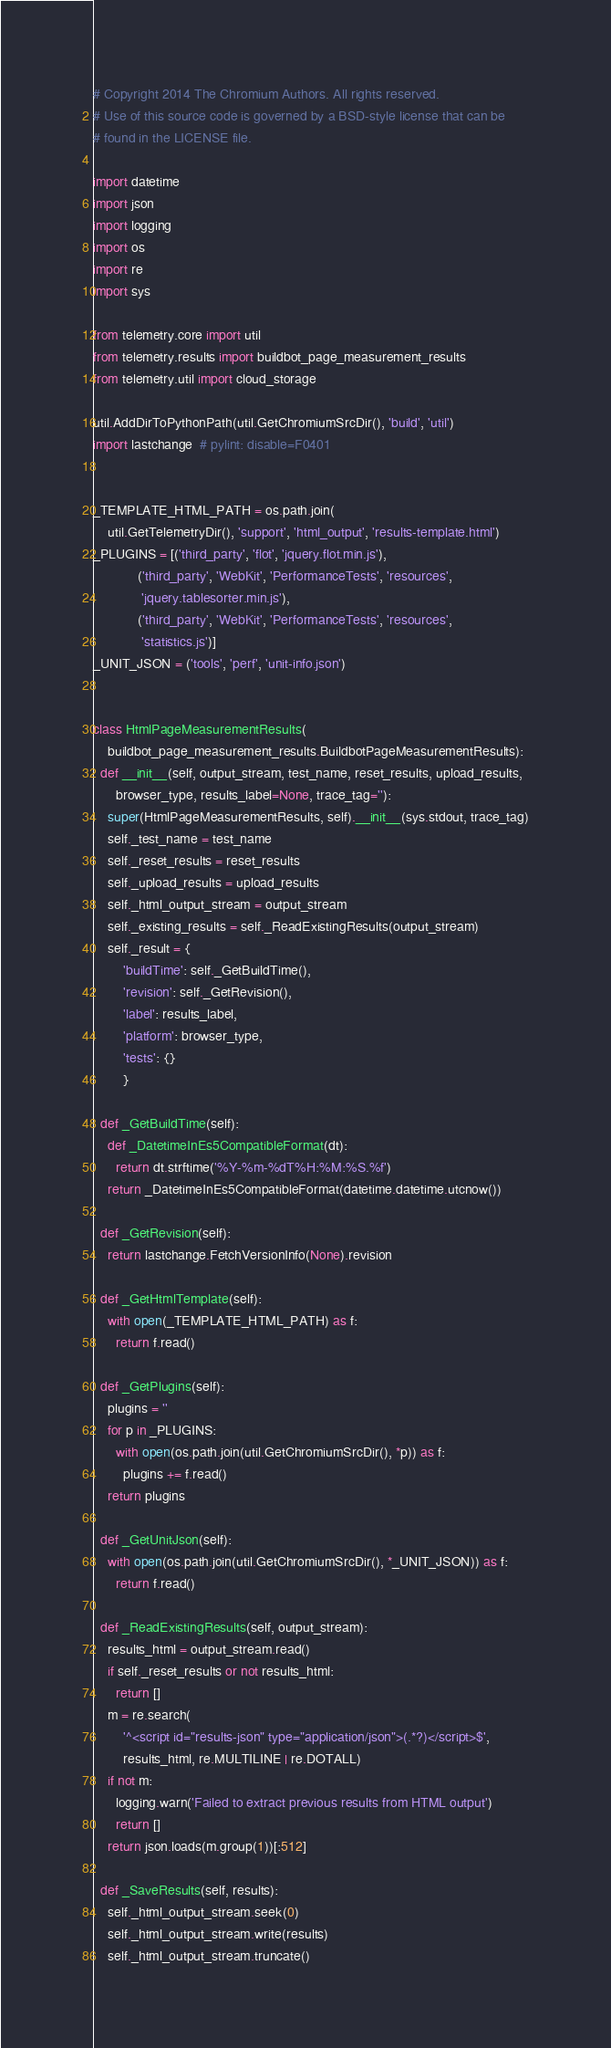<code> <loc_0><loc_0><loc_500><loc_500><_Python_># Copyright 2014 The Chromium Authors. All rights reserved.
# Use of this source code is governed by a BSD-style license that can be
# found in the LICENSE file.

import datetime
import json
import logging
import os
import re
import sys

from telemetry.core import util
from telemetry.results import buildbot_page_measurement_results
from telemetry.util import cloud_storage

util.AddDirToPythonPath(util.GetChromiumSrcDir(), 'build', 'util')
import lastchange  # pylint: disable=F0401


_TEMPLATE_HTML_PATH = os.path.join(
    util.GetTelemetryDir(), 'support', 'html_output', 'results-template.html')
_PLUGINS = [('third_party', 'flot', 'jquery.flot.min.js'),
            ('third_party', 'WebKit', 'PerformanceTests', 'resources',
             'jquery.tablesorter.min.js'),
            ('third_party', 'WebKit', 'PerformanceTests', 'resources',
             'statistics.js')]
_UNIT_JSON = ('tools', 'perf', 'unit-info.json')


class HtmlPageMeasurementResults(
    buildbot_page_measurement_results.BuildbotPageMeasurementResults):
  def __init__(self, output_stream, test_name, reset_results, upload_results,
      browser_type, results_label=None, trace_tag=''):
    super(HtmlPageMeasurementResults, self).__init__(sys.stdout, trace_tag)
    self._test_name = test_name
    self._reset_results = reset_results
    self._upload_results = upload_results
    self._html_output_stream = output_stream
    self._existing_results = self._ReadExistingResults(output_stream)
    self._result = {
        'buildTime': self._GetBuildTime(),
        'revision': self._GetRevision(),
        'label': results_label,
        'platform': browser_type,
        'tests': {}
        }

  def _GetBuildTime(self):
    def _DatetimeInEs5CompatibleFormat(dt):
      return dt.strftime('%Y-%m-%dT%H:%M:%S.%f')
    return _DatetimeInEs5CompatibleFormat(datetime.datetime.utcnow())

  def _GetRevision(self):
    return lastchange.FetchVersionInfo(None).revision

  def _GetHtmlTemplate(self):
    with open(_TEMPLATE_HTML_PATH) as f:
      return f.read()

  def _GetPlugins(self):
    plugins = ''
    for p in _PLUGINS:
      with open(os.path.join(util.GetChromiumSrcDir(), *p)) as f:
        plugins += f.read()
    return plugins

  def _GetUnitJson(self):
    with open(os.path.join(util.GetChromiumSrcDir(), *_UNIT_JSON)) as f:
      return f.read()

  def _ReadExistingResults(self, output_stream):
    results_html = output_stream.read()
    if self._reset_results or not results_html:
      return []
    m = re.search(
        '^<script id="results-json" type="application/json">(.*?)</script>$',
        results_html, re.MULTILINE | re.DOTALL)
    if not m:
      logging.warn('Failed to extract previous results from HTML output')
      return []
    return json.loads(m.group(1))[:512]

  def _SaveResults(self, results):
    self._html_output_stream.seek(0)
    self._html_output_stream.write(results)
    self._html_output_stream.truncate()
</code> 